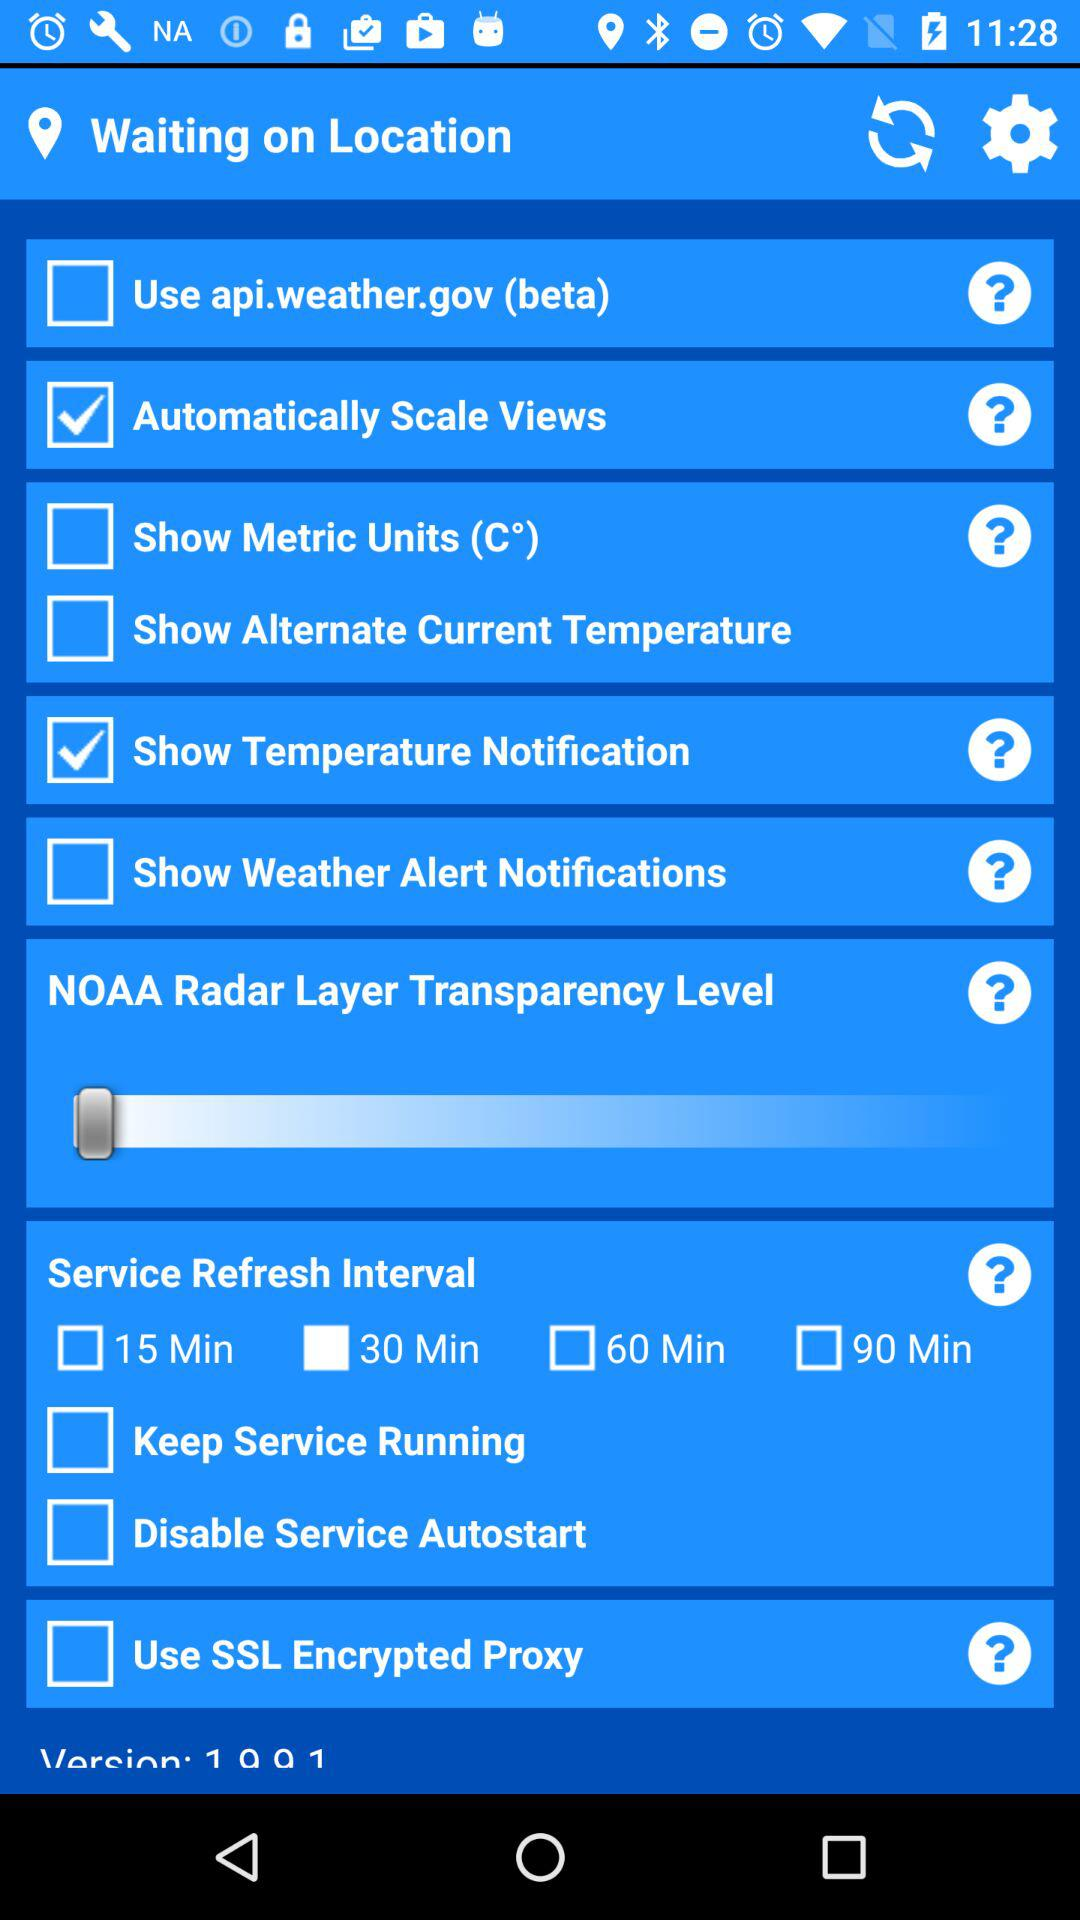What is the service refresh interval time? The service refresh interval time is 30 minutes. 